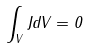Convert formula to latex. <formula><loc_0><loc_0><loc_500><loc_500>\int _ { V } J d V = 0</formula> 